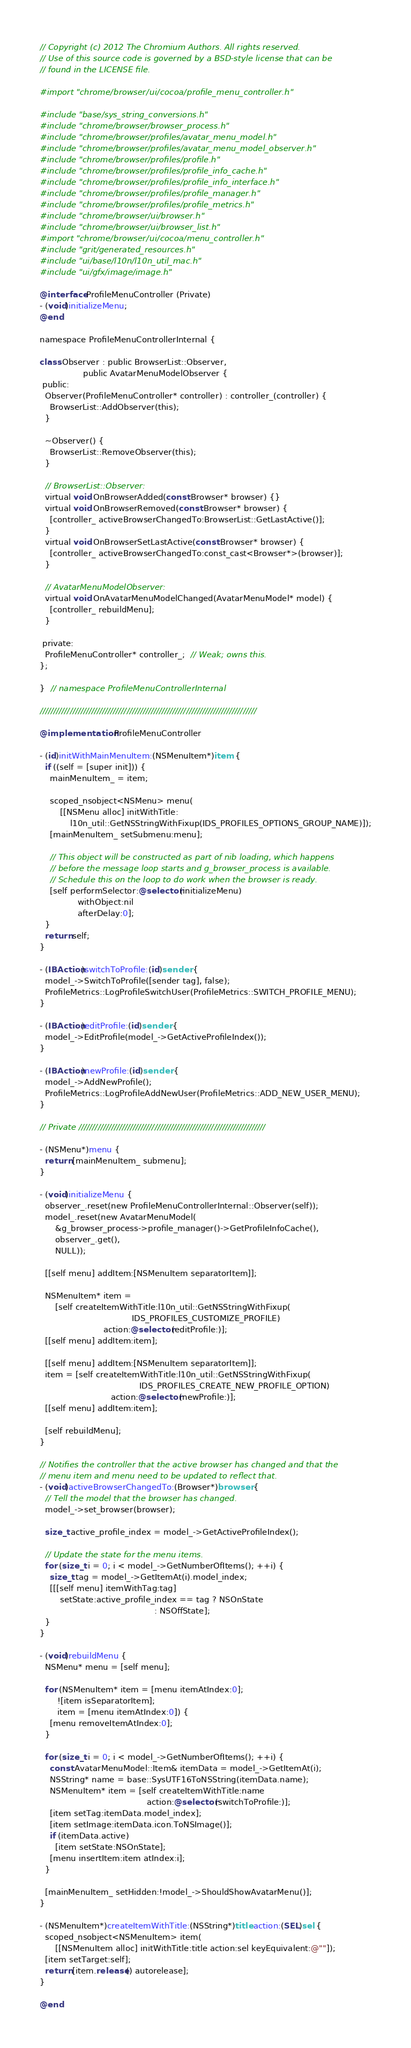<code> <loc_0><loc_0><loc_500><loc_500><_ObjectiveC_>// Copyright (c) 2012 The Chromium Authors. All rights reserved.
// Use of this source code is governed by a BSD-style license that can be
// found in the LICENSE file.

#import "chrome/browser/ui/cocoa/profile_menu_controller.h"

#include "base/sys_string_conversions.h"
#include "chrome/browser/browser_process.h"
#include "chrome/browser/profiles/avatar_menu_model.h"
#include "chrome/browser/profiles/avatar_menu_model_observer.h"
#include "chrome/browser/profiles/profile.h"
#include "chrome/browser/profiles/profile_info_cache.h"
#include "chrome/browser/profiles/profile_info_interface.h"
#include "chrome/browser/profiles/profile_manager.h"
#include "chrome/browser/profiles/profile_metrics.h"
#include "chrome/browser/ui/browser.h"
#include "chrome/browser/ui/browser_list.h"
#import "chrome/browser/ui/cocoa/menu_controller.h"
#include "grit/generated_resources.h"
#include "ui/base/l10n/l10n_util_mac.h"
#include "ui/gfx/image/image.h"

@interface ProfileMenuController (Private)
- (void)initializeMenu;
@end

namespace ProfileMenuControllerInternal {

class Observer : public BrowserList::Observer,
                 public AvatarMenuModelObserver {
 public:
  Observer(ProfileMenuController* controller) : controller_(controller) {
    BrowserList::AddObserver(this);
  }

  ~Observer() {
    BrowserList::RemoveObserver(this);
  }

  // BrowserList::Observer:
  virtual void OnBrowserAdded(const Browser* browser) {}
  virtual void OnBrowserRemoved(const Browser* browser) {
    [controller_ activeBrowserChangedTo:BrowserList::GetLastActive()];
  }
  virtual void OnBrowserSetLastActive(const Browser* browser) {
    [controller_ activeBrowserChangedTo:const_cast<Browser*>(browser)];
  }

  // AvatarMenuModelObserver:
  virtual void OnAvatarMenuModelChanged(AvatarMenuModel* model) {
    [controller_ rebuildMenu];
  }

 private:
  ProfileMenuController* controller_;  // Weak; owns this.
};

}  // namespace ProfileMenuControllerInternal

////////////////////////////////////////////////////////////////////////////////

@implementation ProfileMenuController

- (id)initWithMainMenuItem:(NSMenuItem*)item {
  if ((self = [super init])) {
    mainMenuItem_ = item;

    scoped_nsobject<NSMenu> menu(
        [[NSMenu alloc] initWithTitle:
            l10n_util::GetNSStringWithFixup(IDS_PROFILES_OPTIONS_GROUP_NAME)]);
    [mainMenuItem_ setSubmenu:menu];

    // This object will be constructed as part of nib loading, which happens
    // before the message loop starts and g_browser_process is available.
    // Schedule this on the loop to do work when the browser is ready.
    [self performSelector:@selector(initializeMenu)
               withObject:nil
               afterDelay:0];
  }
  return self;
}

- (IBAction)switchToProfile:(id)sender {
  model_->SwitchToProfile([sender tag], false);
  ProfileMetrics::LogProfileSwitchUser(ProfileMetrics::SWITCH_PROFILE_MENU);
}

- (IBAction)editProfile:(id)sender {
  model_->EditProfile(model_->GetActiveProfileIndex());
}

- (IBAction)newProfile:(id)sender {
  model_->AddNewProfile();
  ProfileMetrics::LogProfileAddNewUser(ProfileMetrics::ADD_NEW_USER_MENU);
}

// Private /////////////////////////////////////////////////////////////////////

- (NSMenu*)menu {
  return [mainMenuItem_ submenu];
}

- (void)initializeMenu {
  observer_.reset(new ProfileMenuControllerInternal::Observer(self));
  model_.reset(new AvatarMenuModel(
      &g_browser_process->profile_manager()->GetProfileInfoCache(),
      observer_.get(),
      NULL));

  [[self menu] addItem:[NSMenuItem separatorItem]];

  NSMenuItem* item =
      [self createItemWithTitle:l10n_util::GetNSStringWithFixup(
                                    IDS_PROFILES_CUSTOMIZE_PROFILE)
                         action:@selector(editProfile:)];
  [[self menu] addItem:item];

  [[self menu] addItem:[NSMenuItem separatorItem]];
  item = [self createItemWithTitle:l10n_util::GetNSStringWithFixup(
                                       IDS_PROFILES_CREATE_NEW_PROFILE_OPTION)
                            action:@selector(newProfile:)];
  [[self menu] addItem:item];

  [self rebuildMenu];
}

// Notifies the controller that the active browser has changed and that the
// menu item and menu need to be updated to reflect that.
- (void)activeBrowserChangedTo:(Browser*)browser {
  // Tell the model that the browser has changed.
  model_->set_browser(browser);

  size_t active_profile_index = model_->GetActiveProfileIndex();

  // Update the state for the menu items.
  for (size_t i = 0; i < model_->GetNumberOfItems(); ++i) {
    size_t tag = model_->GetItemAt(i).model_index;
    [[[self menu] itemWithTag:tag]
        setState:active_profile_index == tag ? NSOnState
                                             : NSOffState];
  }
}

- (void)rebuildMenu {
  NSMenu* menu = [self menu];

  for (NSMenuItem* item = [menu itemAtIndex:0];
       ![item isSeparatorItem];
       item = [menu itemAtIndex:0]) {
    [menu removeItemAtIndex:0];
  }

  for (size_t i = 0; i < model_->GetNumberOfItems(); ++i) {
    const AvatarMenuModel::Item& itemData = model_->GetItemAt(i);
    NSString* name = base::SysUTF16ToNSString(itemData.name);
    NSMenuItem* item = [self createItemWithTitle:name
                                          action:@selector(switchToProfile:)];
    [item setTag:itemData.model_index];
    [item setImage:itemData.icon.ToNSImage()];
    if (itemData.active)
      [item setState:NSOnState];
    [menu insertItem:item atIndex:i];
  }

  [mainMenuItem_ setHidden:!model_->ShouldShowAvatarMenu()];
}

- (NSMenuItem*)createItemWithTitle:(NSString*)title action:(SEL)sel {
  scoped_nsobject<NSMenuItem> item(
      [[NSMenuItem alloc] initWithTitle:title action:sel keyEquivalent:@""]);
  [item setTarget:self];
  return [item.release() autorelease];
}

@end
</code> 